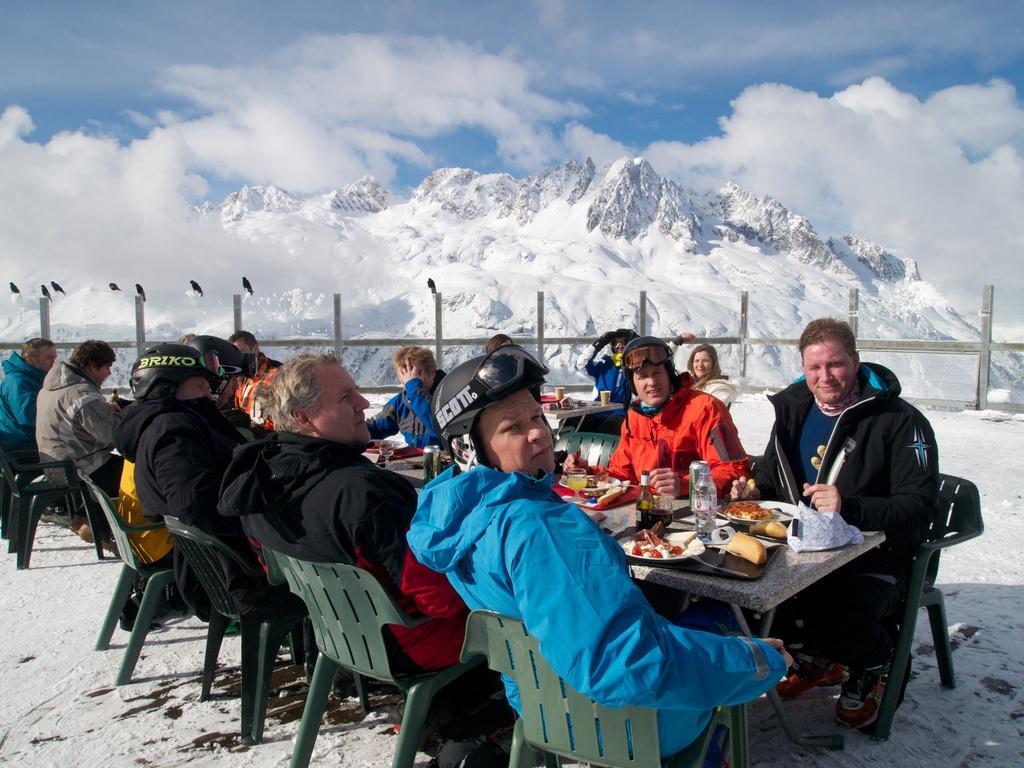Can you describe this image briefly? In this picture we can see group of people sitting on chairs and in front of them there is table and on table we can see bottle, plate, glass with drink in it and some food items and in background we can see fence, birds, mountains, sky with clouds. 